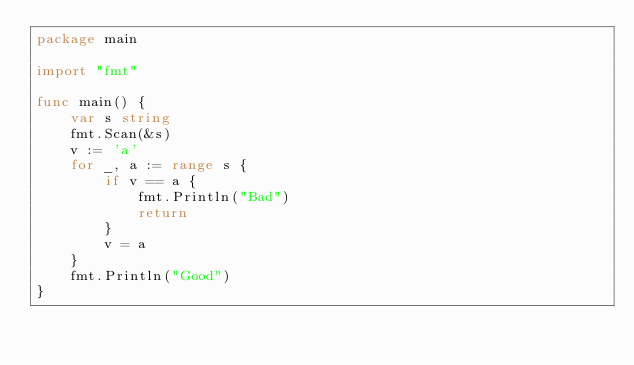<code> <loc_0><loc_0><loc_500><loc_500><_Go_>package main

import "fmt"

func main() {
	var s string
	fmt.Scan(&s)
	v := 'a'
	for _, a := range s {
		if v == a {
			fmt.Println("Bad")
			return
		}
		v = a
	}
	fmt.Println("Good")
}
</code> 